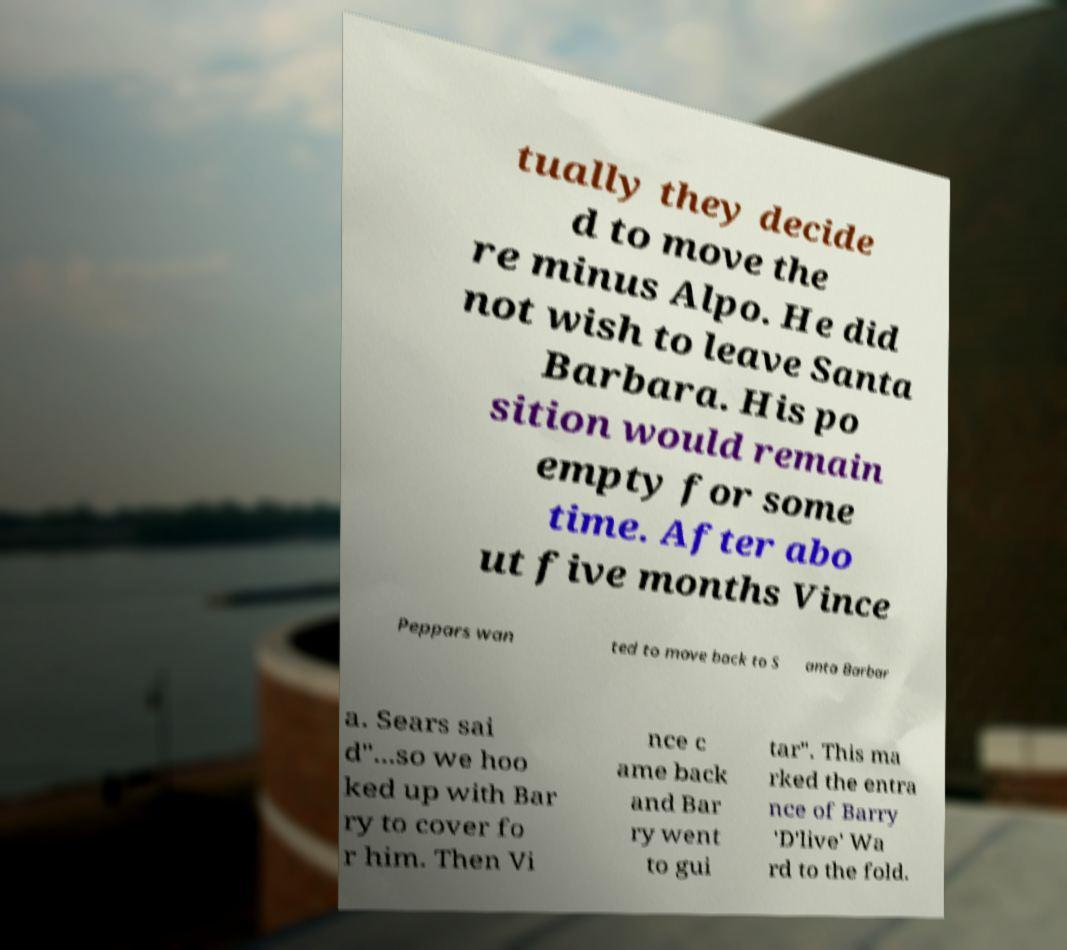Could you extract and type out the text from this image? tually they decide d to move the re minus Alpo. He did not wish to leave Santa Barbara. His po sition would remain empty for some time. After abo ut five months Vince Peppars wan ted to move back to S anta Barbar a. Sears sai d"...so we hoo ked up with Bar ry to cover fo r him. Then Vi nce c ame back and Bar ry went to gui tar". This ma rked the entra nce of Barry 'D'live' Wa rd to the fold. 